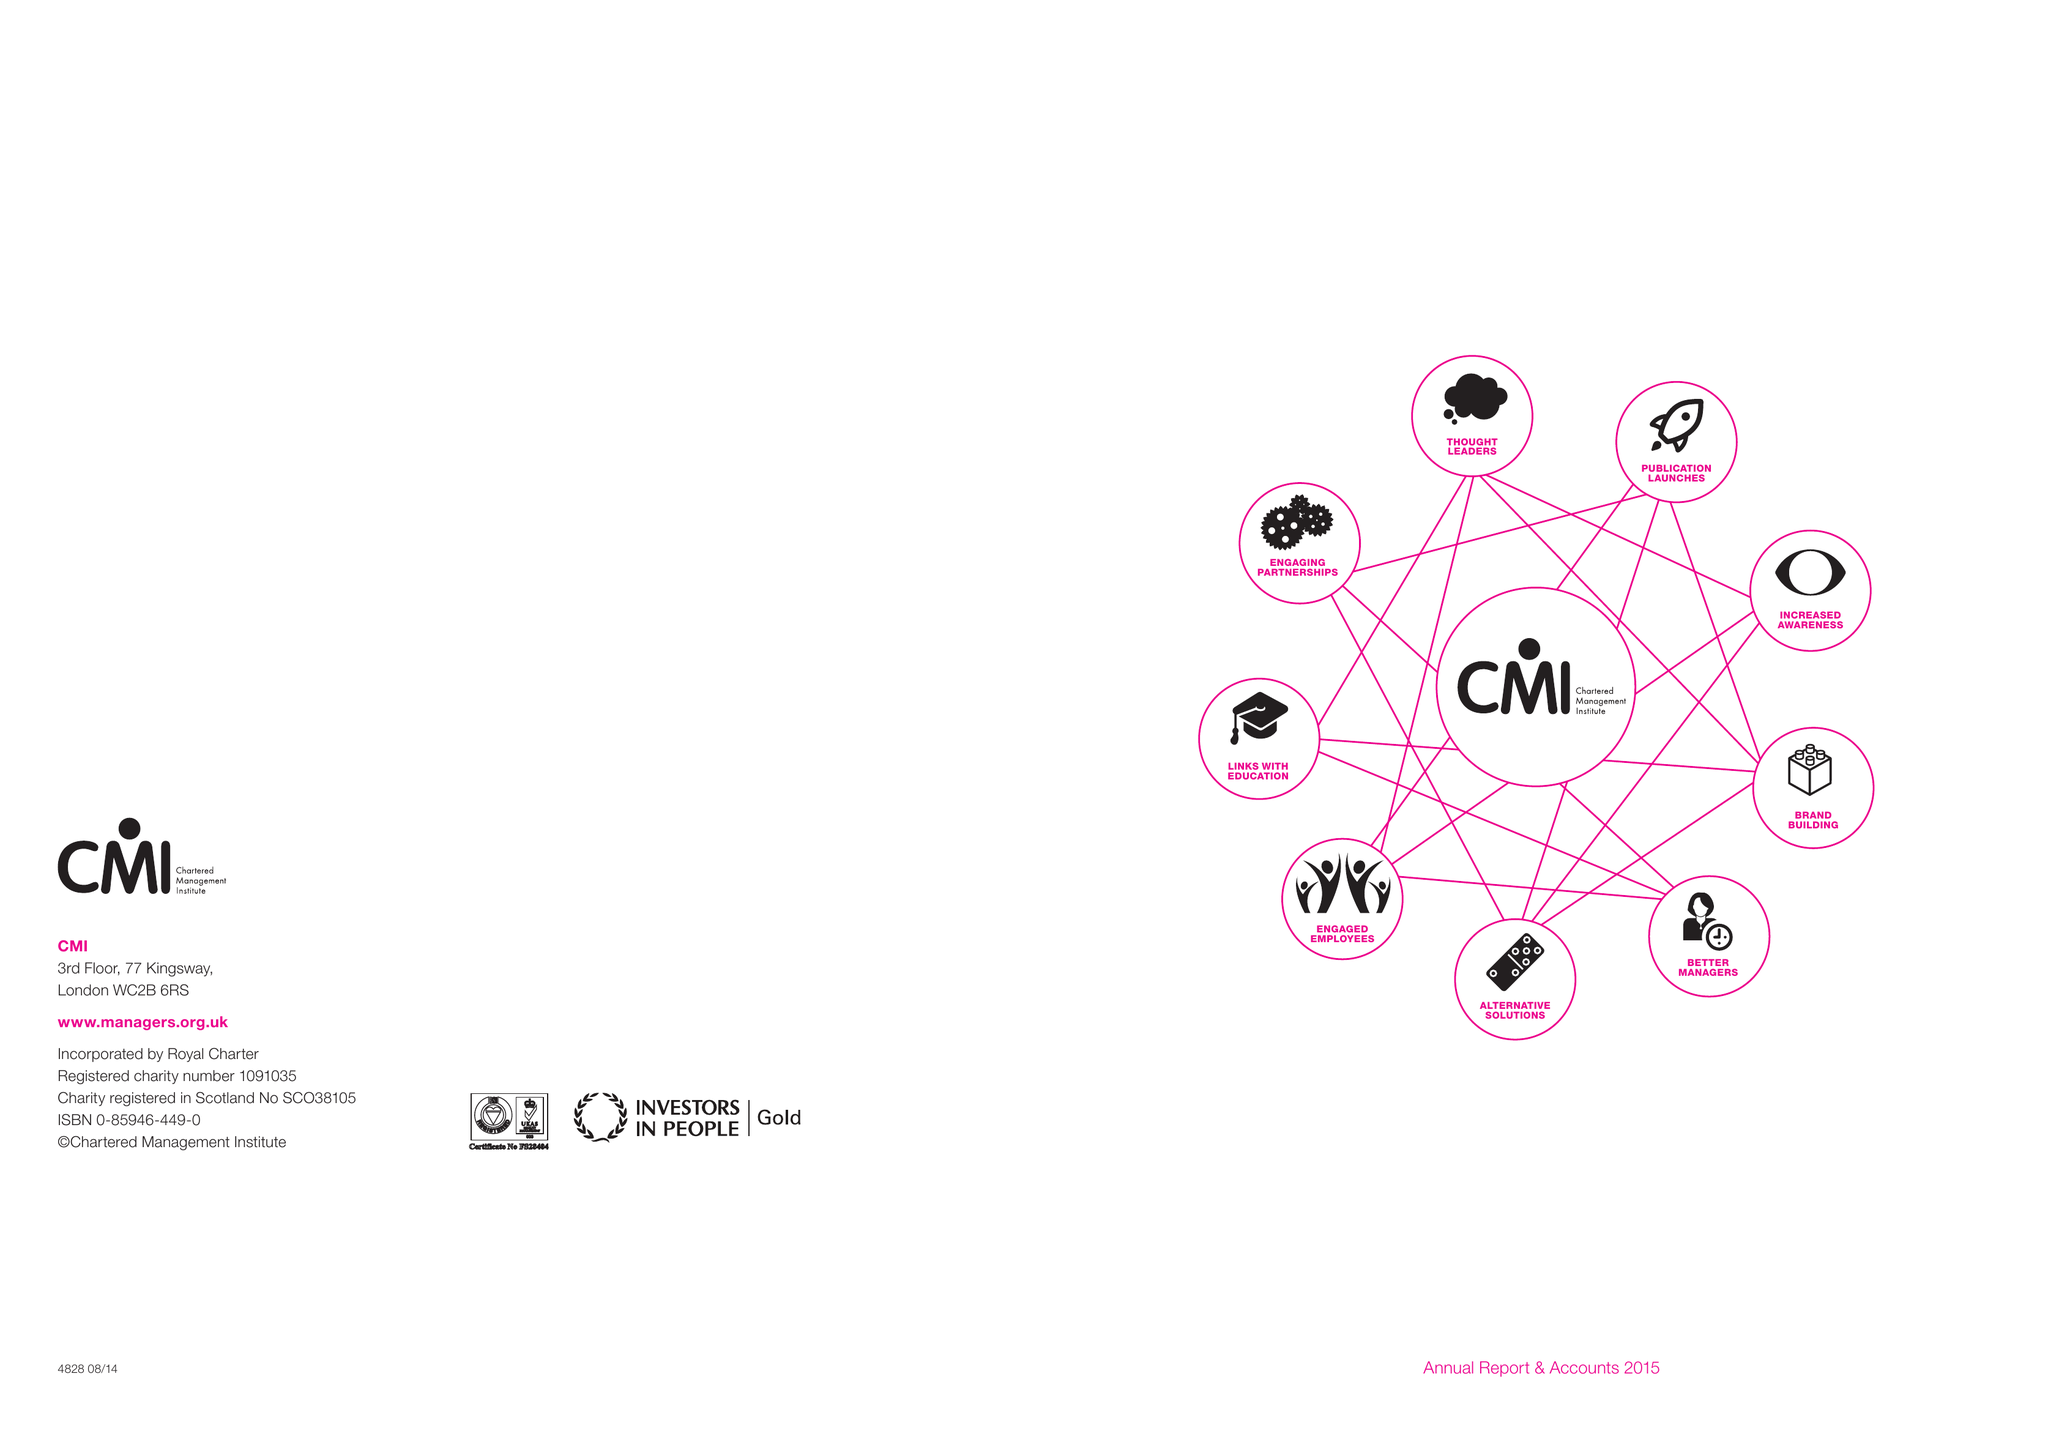What is the value for the address__street_line?
Answer the question using a single word or phrase. COTTINGHAM ROAD 